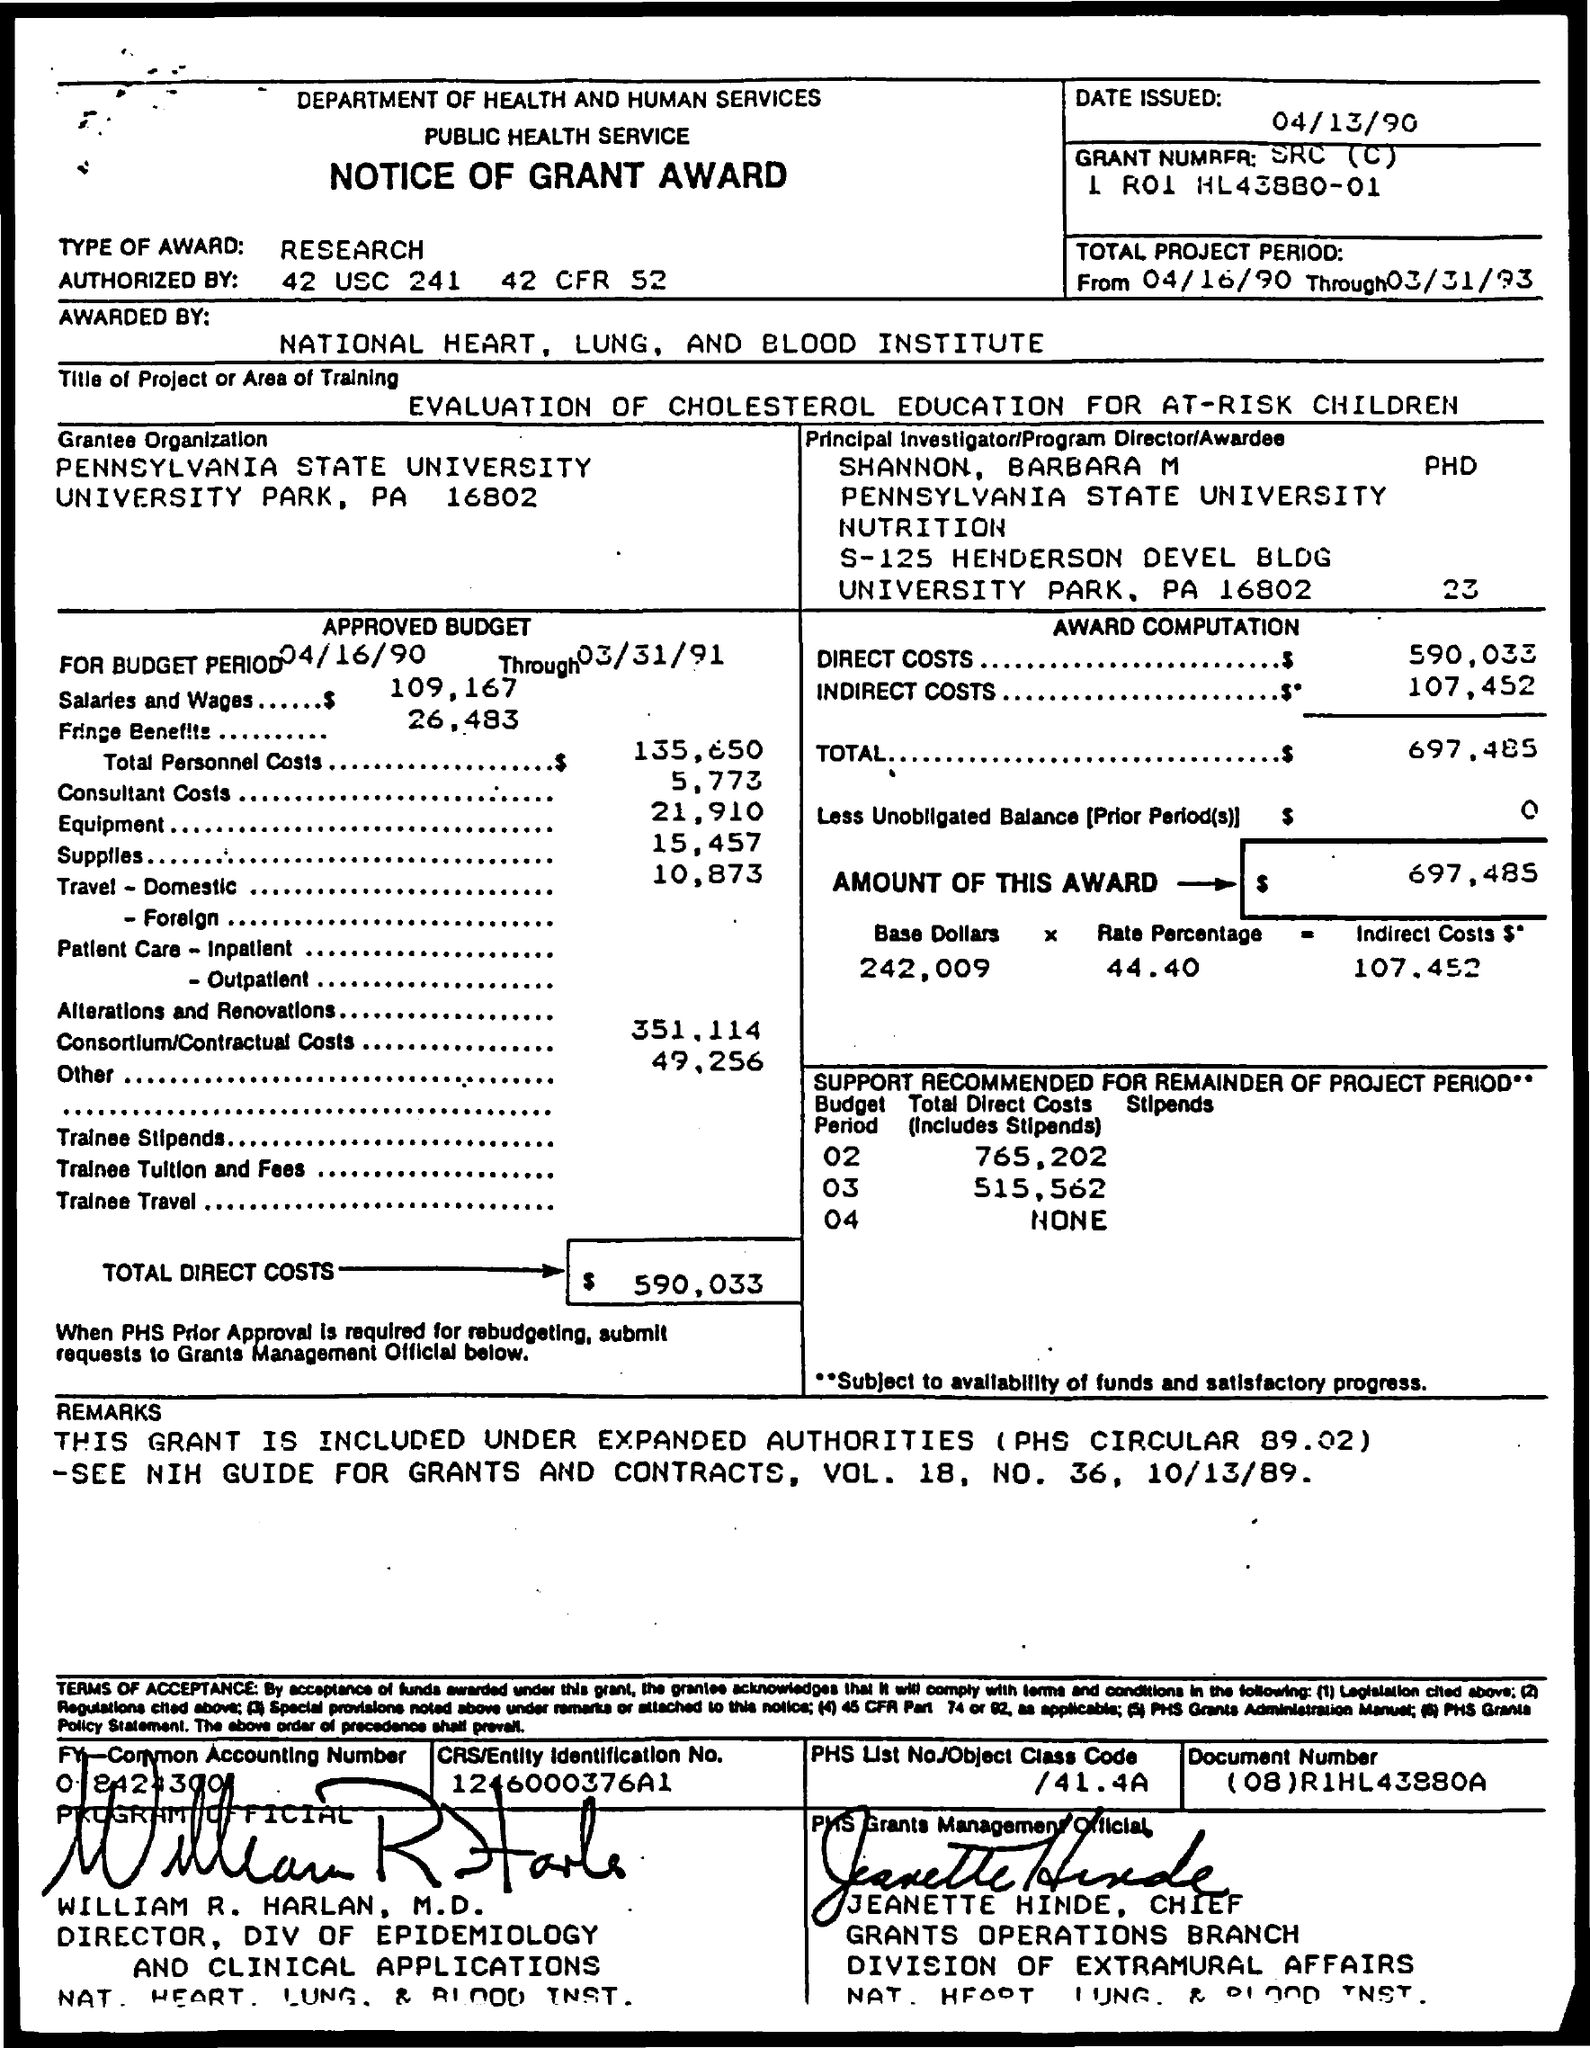What is the Type of Award?
 Research 